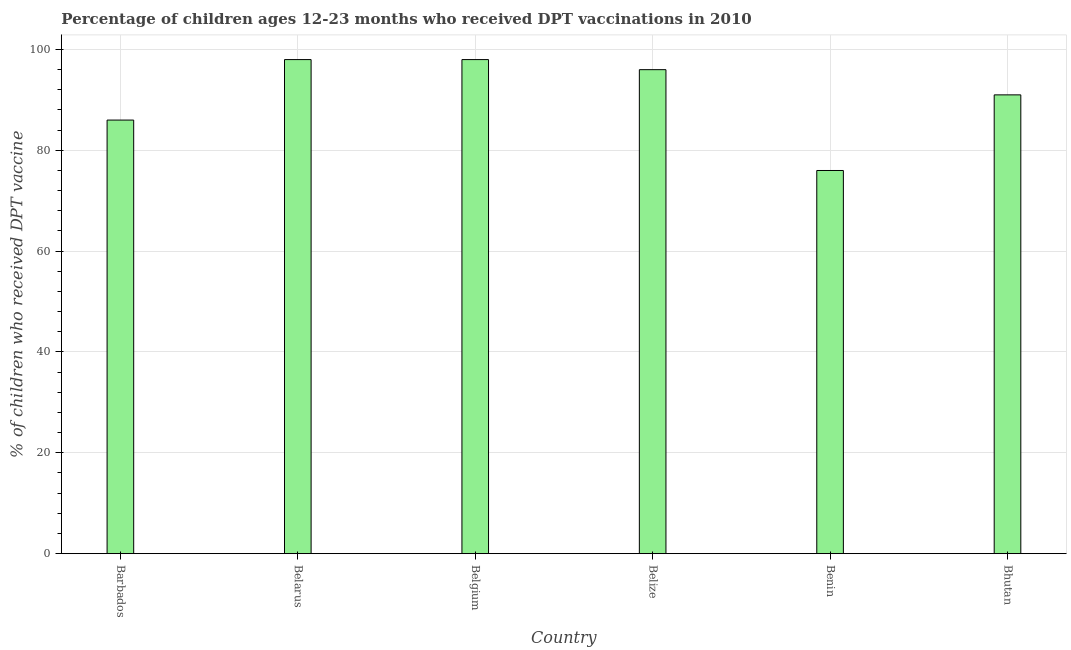Does the graph contain any zero values?
Provide a short and direct response. No. What is the title of the graph?
Give a very brief answer. Percentage of children ages 12-23 months who received DPT vaccinations in 2010. What is the label or title of the X-axis?
Offer a terse response. Country. What is the label or title of the Y-axis?
Ensure brevity in your answer.  % of children who received DPT vaccine. In which country was the percentage of children who received dpt vaccine maximum?
Offer a terse response. Belarus. In which country was the percentage of children who received dpt vaccine minimum?
Ensure brevity in your answer.  Benin. What is the sum of the percentage of children who received dpt vaccine?
Your answer should be very brief. 545. What is the average percentage of children who received dpt vaccine per country?
Offer a very short reply. 90.83. What is the median percentage of children who received dpt vaccine?
Your answer should be compact. 93.5. What is the ratio of the percentage of children who received dpt vaccine in Belarus to that in Benin?
Keep it short and to the point. 1.29. Is the sum of the percentage of children who received dpt vaccine in Belarus and Bhutan greater than the maximum percentage of children who received dpt vaccine across all countries?
Your answer should be compact. Yes. Are all the bars in the graph horizontal?
Give a very brief answer. No. How many countries are there in the graph?
Your response must be concise. 6. What is the % of children who received DPT vaccine of Belarus?
Provide a short and direct response. 98. What is the % of children who received DPT vaccine in Belgium?
Your response must be concise. 98. What is the % of children who received DPT vaccine of Belize?
Your answer should be compact. 96. What is the % of children who received DPT vaccine in Bhutan?
Provide a short and direct response. 91. What is the difference between the % of children who received DPT vaccine in Barbados and Belgium?
Your response must be concise. -12. What is the difference between the % of children who received DPT vaccine in Barbados and Bhutan?
Offer a very short reply. -5. What is the difference between the % of children who received DPT vaccine in Belgium and Belize?
Provide a short and direct response. 2. What is the difference between the % of children who received DPT vaccine in Belgium and Bhutan?
Provide a succinct answer. 7. What is the difference between the % of children who received DPT vaccine in Belize and Benin?
Give a very brief answer. 20. What is the difference between the % of children who received DPT vaccine in Belize and Bhutan?
Provide a succinct answer. 5. What is the difference between the % of children who received DPT vaccine in Benin and Bhutan?
Keep it short and to the point. -15. What is the ratio of the % of children who received DPT vaccine in Barbados to that in Belarus?
Offer a terse response. 0.88. What is the ratio of the % of children who received DPT vaccine in Barbados to that in Belgium?
Offer a very short reply. 0.88. What is the ratio of the % of children who received DPT vaccine in Barbados to that in Belize?
Keep it short and to the point. 0.9. What is the ratio of the % of children who received DPT vaccine in Barbados to that in Benin?
Your answer should be very brief. 1.13. What is the ratio of the % of children who received DPT vaccine in Barbados to that in Bhutan?
Offer a very short reply. 0.94. What is the ratio of the % of children who received DPT vaccine in Belarus to that in Belgium?
Keep it short and to the point. 1. What is the ratio of the % of children who received DPT vaccine in Belarus to that in Belize?
Your answer should be very brief. 1.02. What is the ratio of the % of children who received DPT vaccine in Belarus to that in Benin?
Your response must be concise. 1.29. What is the ratio of the % of children who received DPT vaccine in Belarus to that in Bhutan?
Keep it short and to the point. 1.08. What is the ratio of the % of children who received DPT vaccine in Belgium to that in Benin?
Give a very brief answer. 1.29. What is the ratio of the % of children who received DPT vaccine in Belgium to that in Bhutan?
Provide a succinct answer. 1.08. What is the ratio of the % of children who received DPT vaccine in Belize to that in Benin?
Provide a short and direct response. 1.26. What is the ratio of the % of children who received DPT vaccine in Belize to that in Bhutan?
Ensure brevity in your answer.  1.05. What is the ratio of the % of children who received DPT vaccine in Benin to that in Bhutan?
Give a very brief answer. 0.83. 